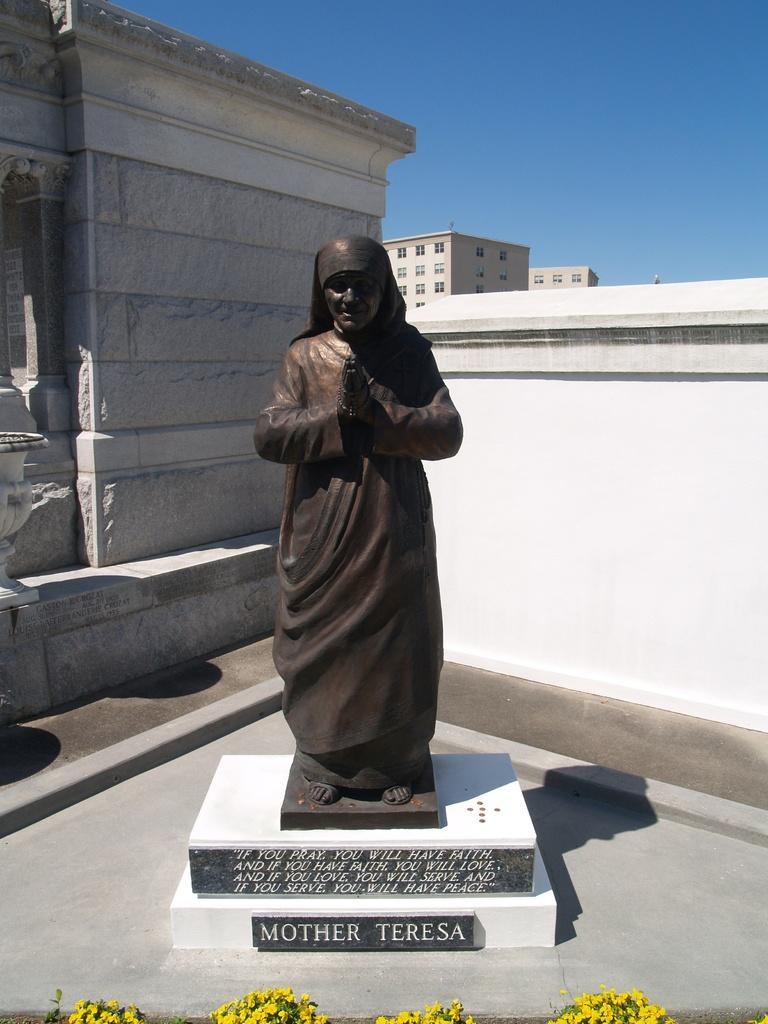Could you give a brief overview of what you see in this image? At the bottom of the image we can see a few flowers, which are in yellow color. In the center of the image we can see one stone. On the stone, we can see some text and one statue, which is in black color. And we can see on the stone, it is written as "Mother Teresa". In the background we can see the sky, buildings, windows and a few other objects. 